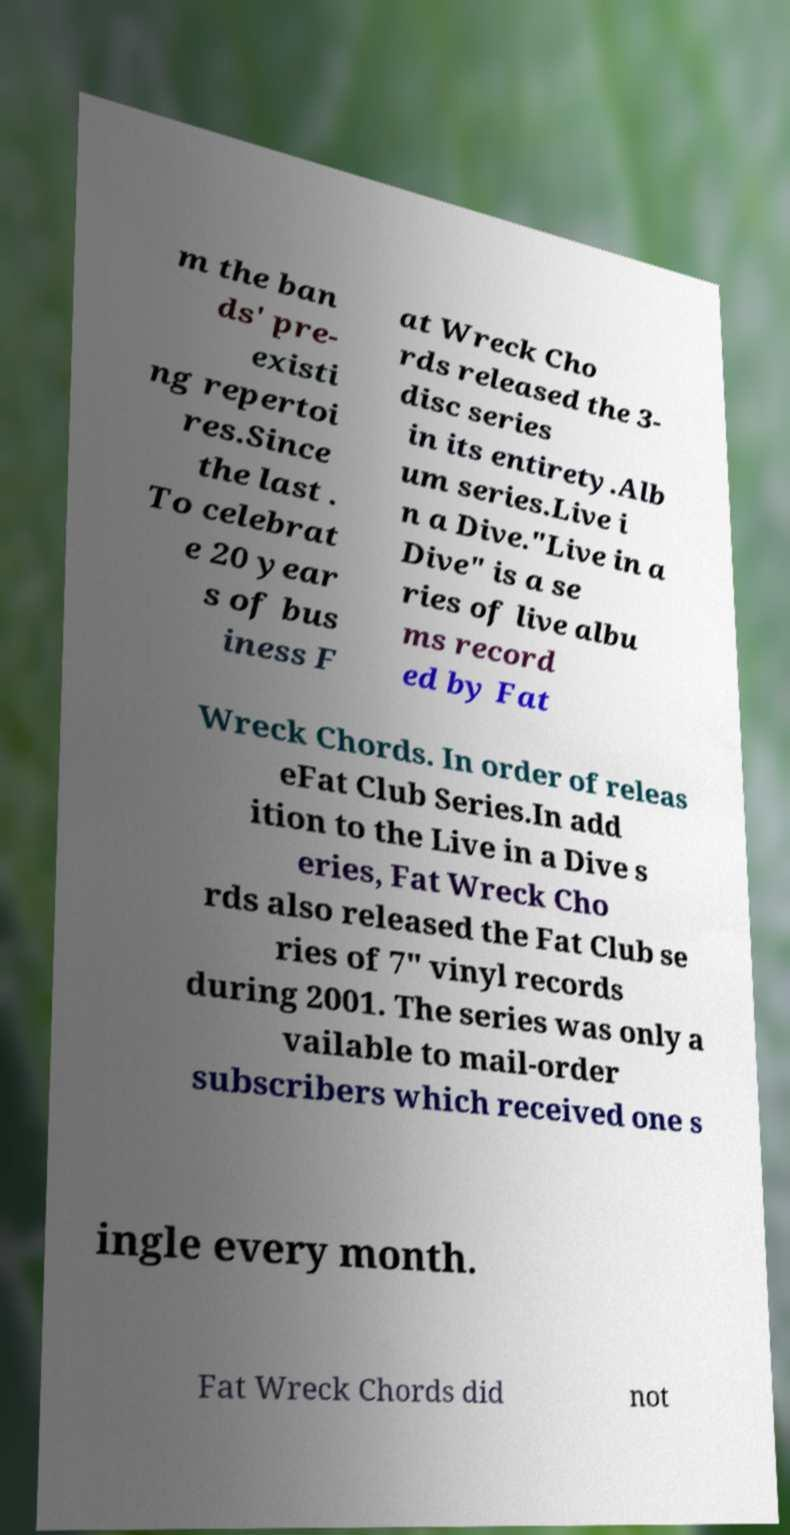Please identify and transcribe the text found in this image. m the ban ds' pre- existi ng repertoi res.Since the last . To celebrat e 20 year s of bus iness F at Wreck Cho rds released the 3- disc series in its entirety.Alb um series.Live i n a Dive."Live in a Dive" is a se ries of live albu ms record ed by Fat Wreck Chords. In order of releas eFat Club Series.In add ition to the Live in a Dive s eries, Fat Wreck Cho rds also released the Fat Club se ries of 7" vinyl records during 2001. The series was only a vailable to mail-order subscribers which received one s ingle every month. Fat Wreck Chords did not 